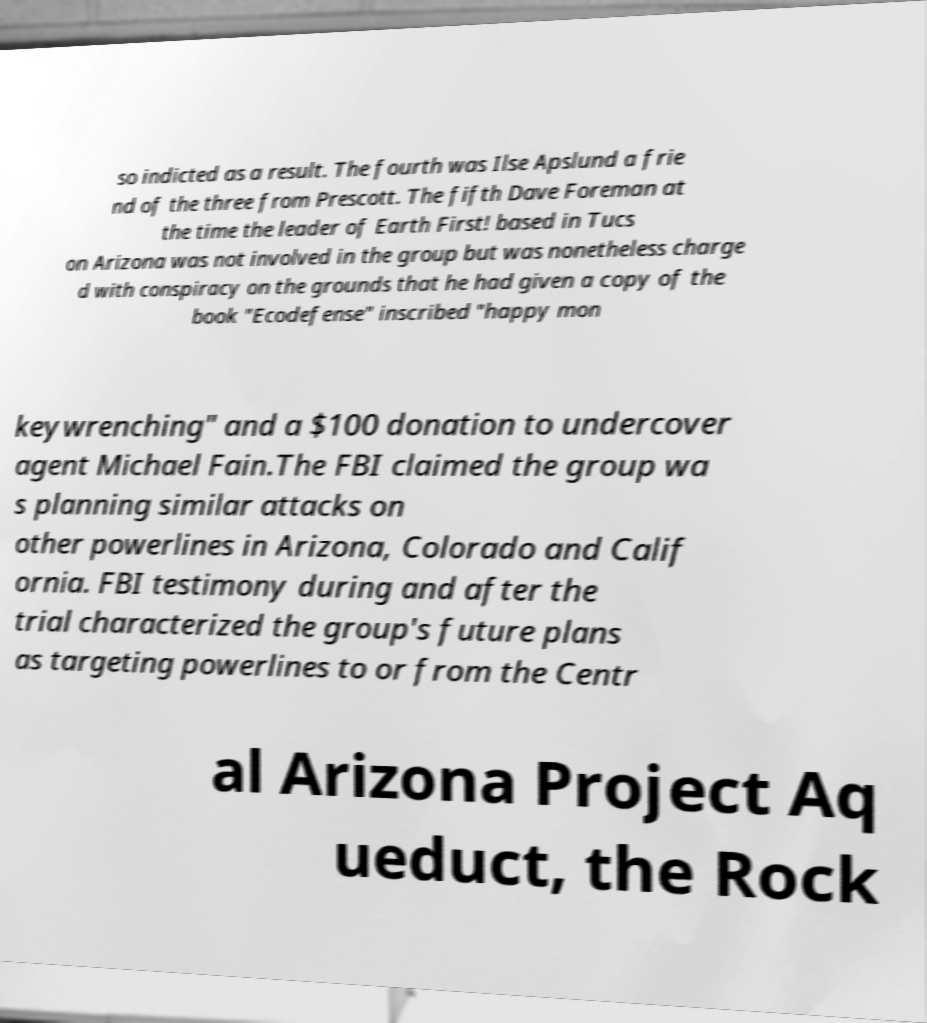Could you extract and type out the text from this image? so indicted as a result. The fourth was Ilse Apslund a frie nd of the three from Prescott. The fifth Dave Foreman at the time the leader of Earth First! based in Tucs on Arizona was not involved in the group but was nonetheless charge d with conspiracy on the grounds that he had given a copy of the book "Ecodefense" inscribed "happy mon keywrenching" and a $100 donation to undercover agent Michael Fain.The FBI claimed the group wa s planning similar attacks on other powerlines in Arizona, Colorado and Calif ornia. FBI testimony during and after the trial characterized the group's future plans as targeting powerlines to or from the Centr al Arizona Project Aq ueduct, the Rock 